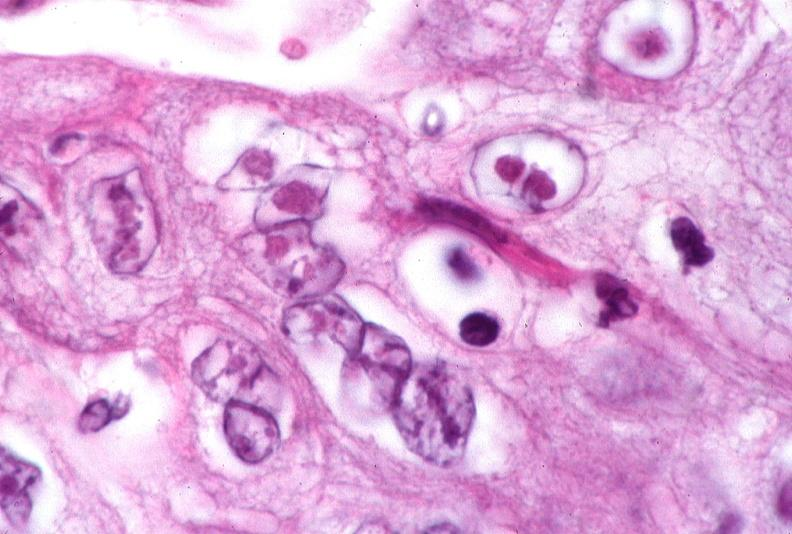where is this?
Answer the question using a single word or phrase. Skin 